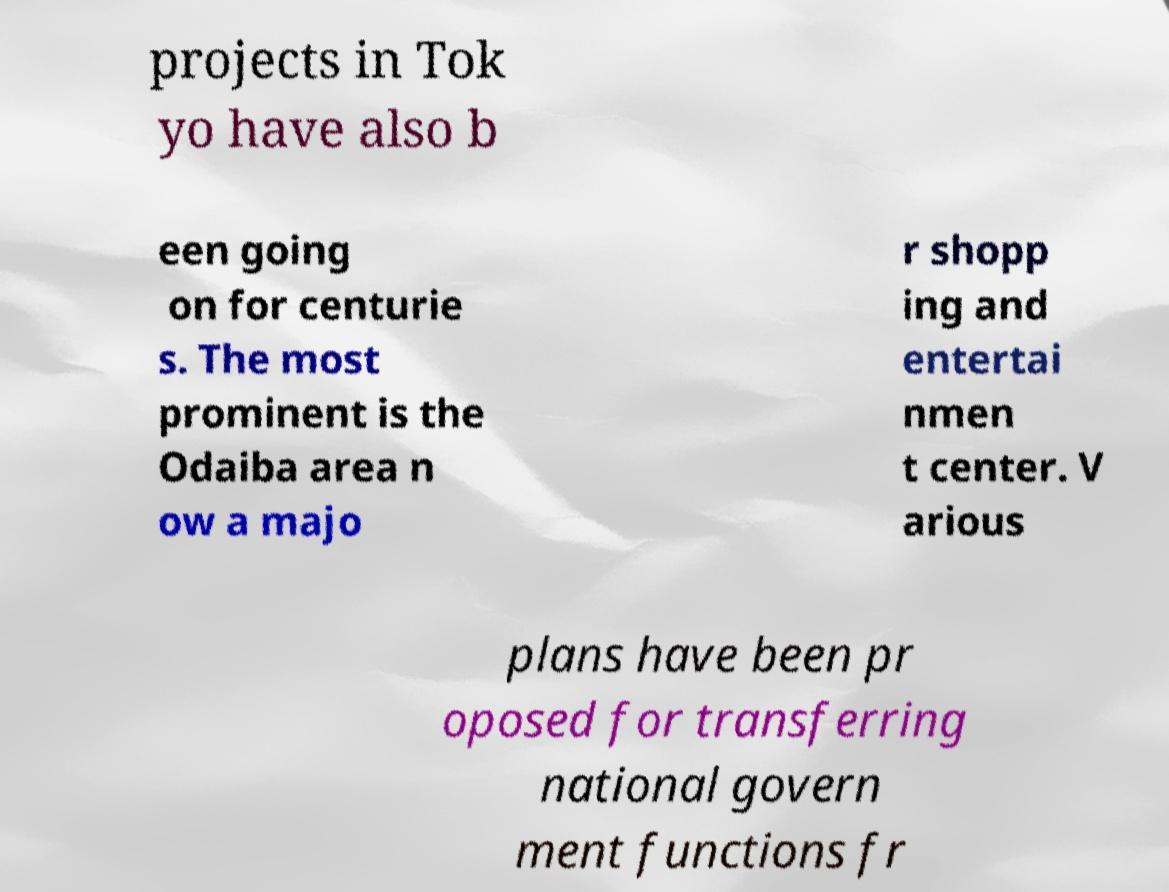Please read and relay the text visible in this image. What does it say? projects in Tok yo have also b een going on for centurie s. The most prominent is the Odaiba area n ow a majo r shopp ing and entertai nmen t center. V arious plans have been pr oposed for transferring national govern ment functions fr 